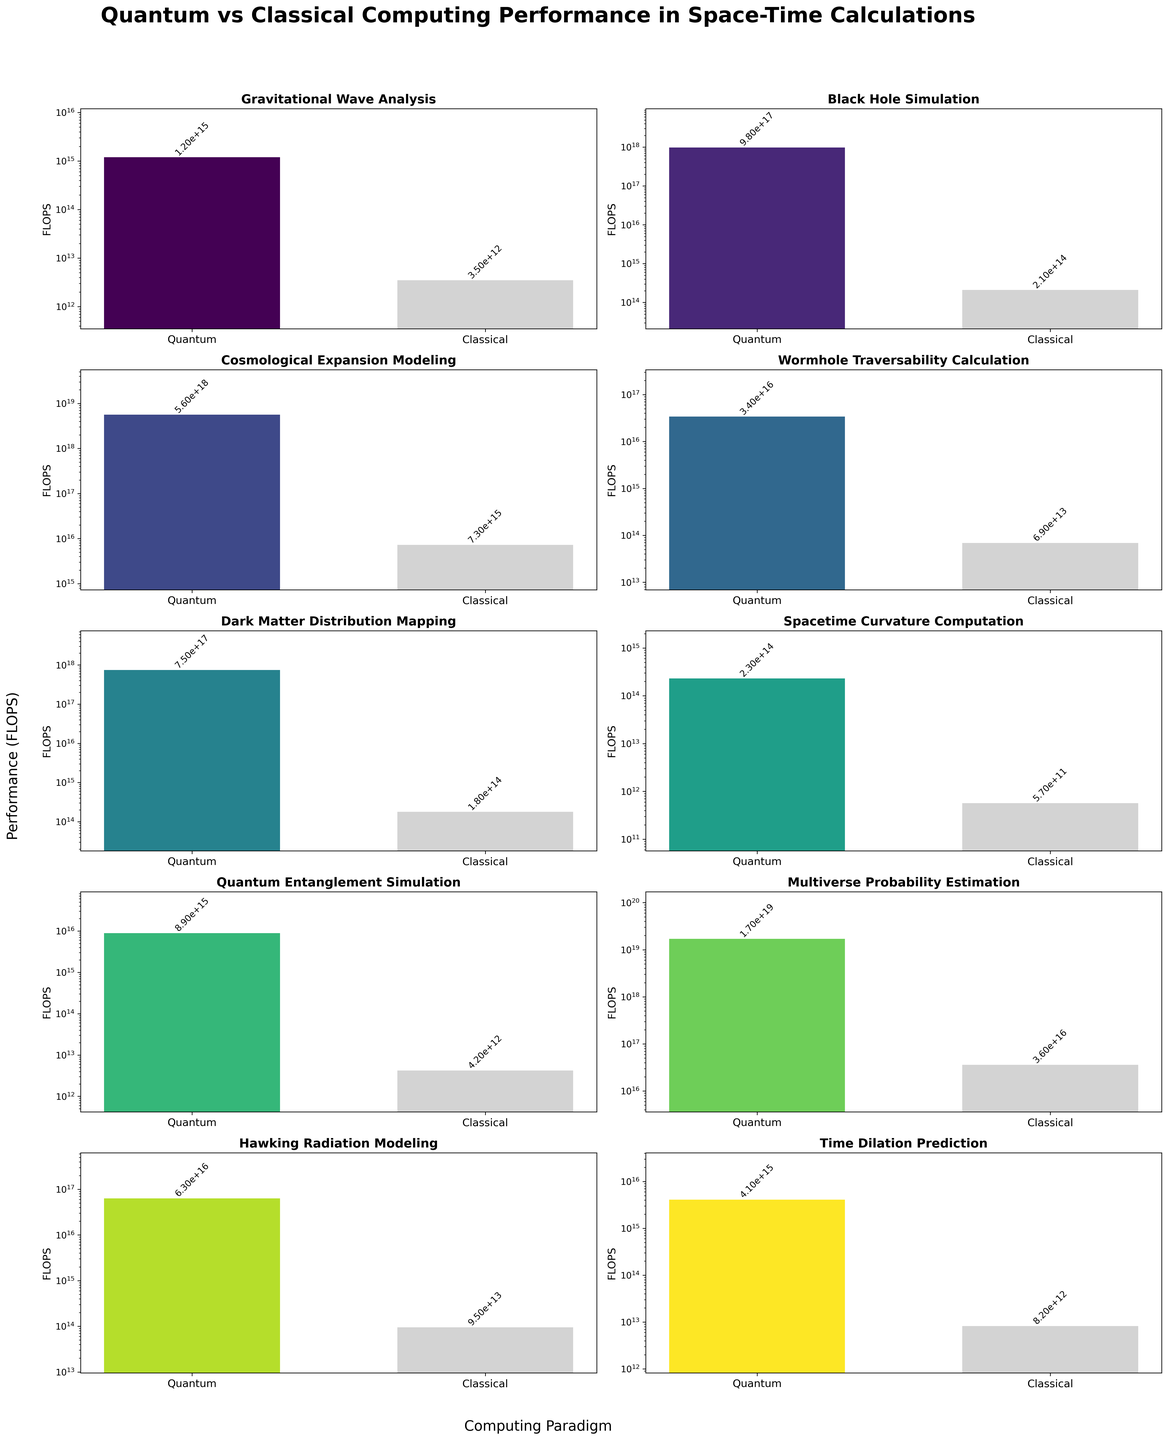What is the title of the figure? The title is usually displayed at the top of the figure. By looking at the top of the plot, it reads "Quantum vs Classical Computing Performance in Space-Time Calculations".
Answer: Quantum vs Classical Computing Performance in Space-Time Calculations Which computation problem reported the highest quantum performance in FLOPS? By examining the heights of the bars labeled "Quantum" in each subplot, the Multiverse Probability Estimation problem in the Multidimensional scale has the highest bar, indicating the maximum performance of approximately 1.7e19 FLOPS.
Answer: Multiverse Probability Estimation How many subplots are in the figure? The figure contains a grid of subplots. By counting both rows and columns, there are 5 rows and 2 columns, resulting in a total of 5 * 2 = 10 subplots.
Answer: 10 What is the y-axis label and what does it represent? The y-axis label is a single label used consistently across the subplots. It is located to the left of the subplot grid and reads "Performance (FLOPS)" which represents the Floating Point Operations Per Second, a measure of computing performance.
Answer: Performance (FLOPS) By how much does the quantum performance exceed the classical performance for Gravitational Wave Analysis? Gravitational Wave Analysis has a quantum performance of 1.2e15 FLOPS and classical performance of 3.5e12 FLOPS. The difference is 1.2e15 - 3.5e12 = 1.1965e15 FLOPS.
Answer: 1.1965e15 FLOPS For which problem is the performance ratio between quantum and classical computers the largest? Calculate the ratio (Quantum/Classical) for each problem and compare. The Multiverse Probability Estimation problem shows a ratio of 1.7e19 / 3.6e16 = 4722.22, which is the largest compared to other problems.
Answer: Multiverse Probability Estimation Which computation problem at the Event Horizon scale has a better performance under the classical paradigm than another problem under the quantum paradigm? Comparing subplots, we see the classical performance in Event Horizon (9.5e13 FLOPS) is greater than the quantum performance of Spacetime Curvature Computation at the Planetary scale (~2.3e14 FLOPS) because 9.5e13 < 2.3e14.
Answer: None What’s the average quantum performance (FLOPS) among the given problems? Sum the quantum performance values and divide by the number of problems. (1.2e15 + 9.8e17 + 5.6e18 + 3.4e16 + 7.5e17 + 2.3e14 + 8.9e15 + 1.7e19 + 6.3e16 + 4.1e15) / 10 = 2.4625e18.
Answer: 2.4625e18 Is there any problem where classical computers outperformed quantum computers? By examining each subplot, no classical bar is taller than its corresponding quantum bar in any subplot, indicating quantum computers outperformed in all problems.
Answer: No 